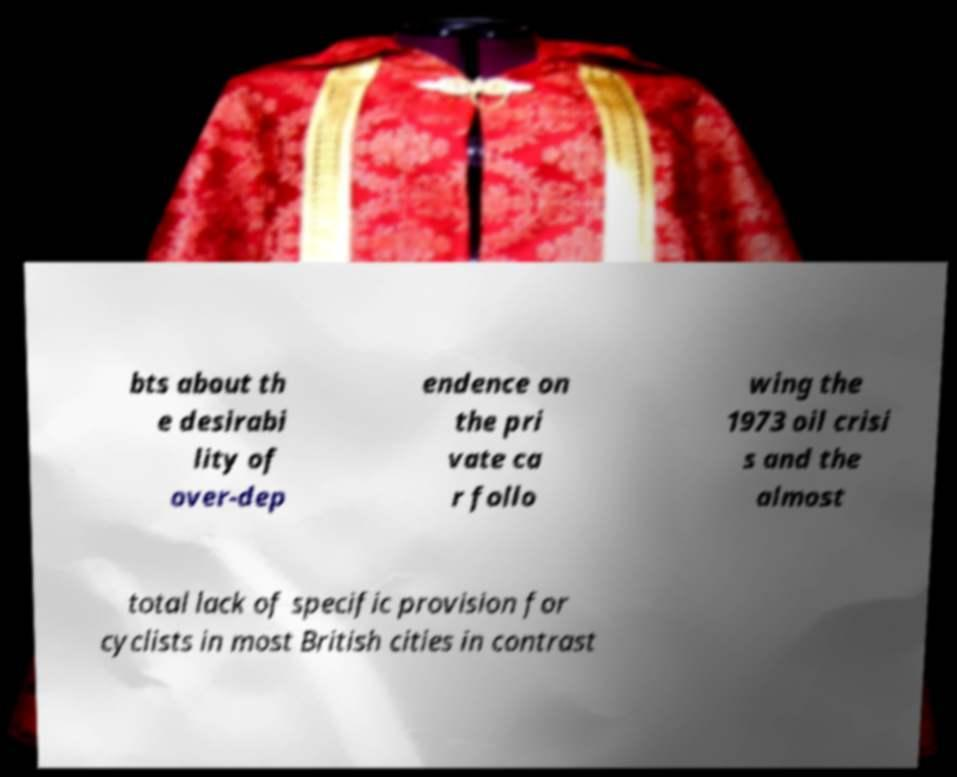There's text embedded in this image that I need extracted. Can you transcribe it verbatim? bts about th e desirabi lity of over-dep endence on the pri vate ca r follo wing the 1973 oil crisi s and the almost total lack of specific provision for cyclists in most British cities in contrast 